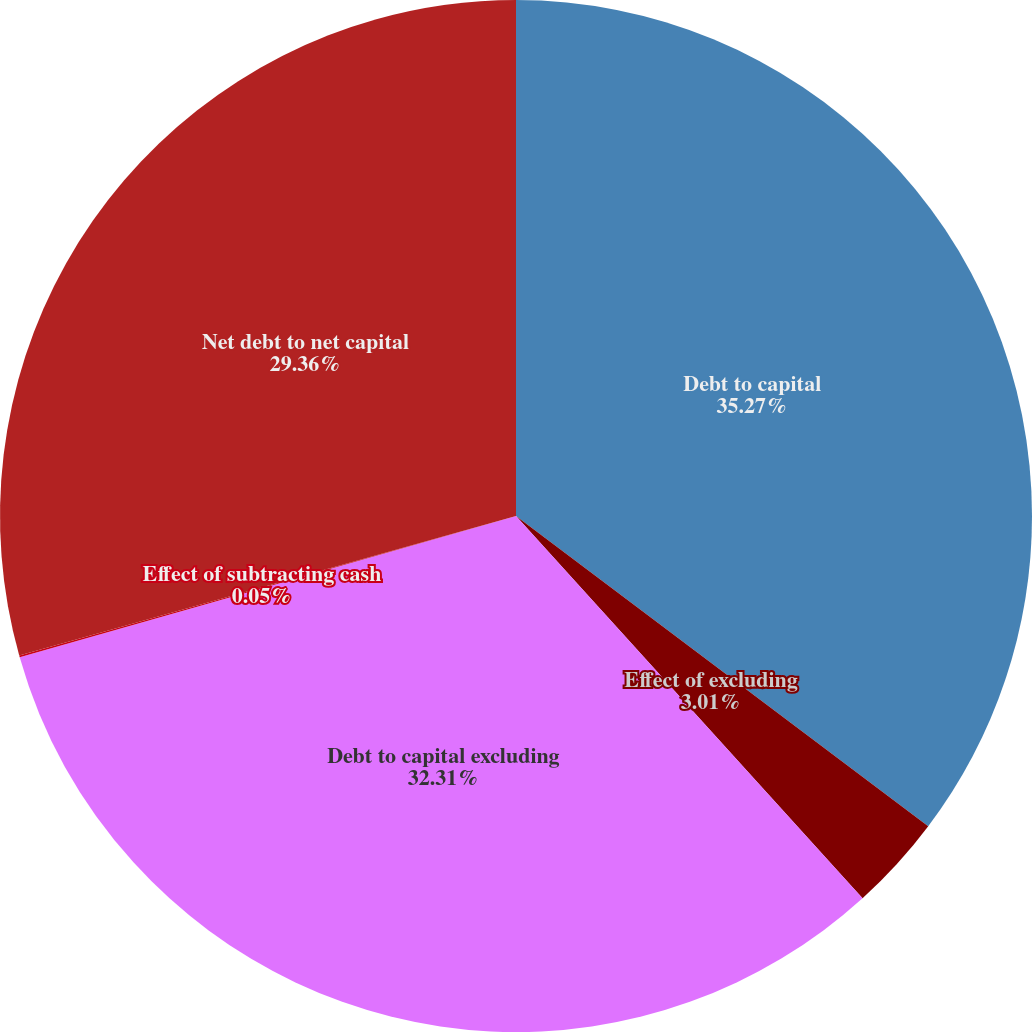Convert chart. <chart><loc_0><loc_0><loc_500><loc_500><pie_chart><fcel>Debt to capital<fcel>Effect of excluding<fcel>Debt to capital excluding<fcel>Effect of subtracting cash<fcel>Net debt to net capital<nl><fcel>35.27%<fcel>3.01%<fcel>32.31%<fcel>0.05%<fcel>29.36%<nl></chart> 